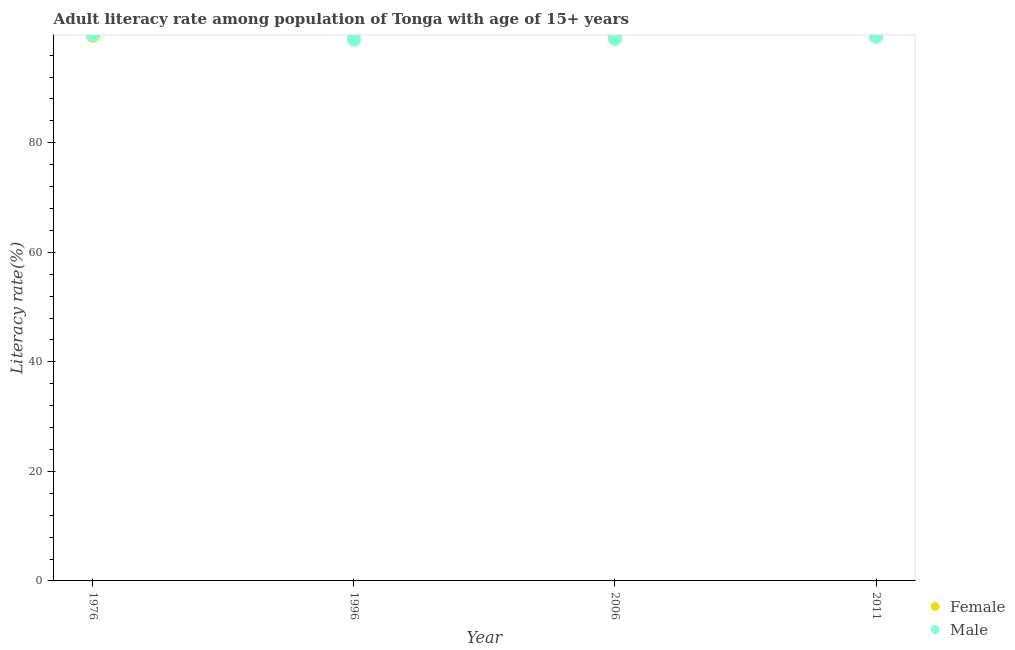What is the female adult literacy rate in 1976?
Your answer should be very brief. 99.53. Across all years, what is the maximum female adult literacy rate?
Ensure brevity in your answer.  99.53. Across all years, what is the minimum male adult literacy rate?
Give a very brief answer. 98.83. In which year was the male adult literacy rate maximum?
Your answer should be very brief. 1976. In which year was the female adult literacy rate minimum?
Offer a terse response. 1996. What is the total female adult literacy rate in the graph?
Provide a short and direct response. 397.02. What is the difference between the male adult literacy rate in 1996 and that in 2011?
Your answer should be very brief. -0.5. What is the difference between the male adult literacy rate in 2011 and the female adult literacy rate in 1976?
Offer a very short reply. -0.19. What is the average female adult literacy rate per year?
Make the answer very short. 99.25. In the year 1996, what is the difference between the male adult literacy rate and female adult literacy rate?
Offer a terse response. -0.14. In how many years, is the female adult literacy rate greater than 16 %?
Your response must be concise. 4. What is the ratio of the female adult literacy rate in 2006 to that in 2011?
Your answer should be compact. 1. What is the difference between the highest and the second highest male adult literacy rate?
Give a very brief answer. 0.32. What is the difference between the highest and the lowest male adult literacy rate?
Offer a very short reply. 0.82. Is the sum of the female adult literacy rate in 2006 and 2011 greater than the maximum male adult literacy rate across all years?
Your answer should be compact. Yes. Is the female adult literacy rate strictly greater than the male adult literacy rate over the years?
Offer a terse response. No. How many dotlines are there?
Make the answer very short. 2. How many years are there in the graph?
Offer a very short reply. 4. What is the difference between two consecutive major ticks on the Y-axis?
Your answer should be compact. 20. Does the graph contain any zero values?
Make the answer very short. No. Does the graph contain grids?
Offer a very short reply. No. Where does the legend appear in the graph?
Offer a very short reply. Bottom right. How many legend labels are there?
Provide a short and direct response. 2. How are the legend labels stacked?
Provide a short and direct response. Vertical. What is the title of the graph?
Keep it short and to the point. Adult literacy rate among population of Tonga with age of 15+ years. What is the label or title of the Y-axis?
Your answer should be compact. Literacy rate(%). What is the Literacy rate(%) of Female in 1976?
Keep it short and to the point. 99.53. What is the Literacy rate(%) in Male in 1976?
Offer a terse response. 99.66. What is the Literacy rate(%) in Female in 1996?
Make the answer very short. 98.98. What is the Literacy rate(%) of Male in 1996?
Ensure brevity in your answer.  98.83. What is the Literacy rate(%) in Female in 2006?
Your answer should be compact. 99.08. What is the Literacy rate(%) in Male in 2006?
Offer a terse response. 98.95. What is the Literacy rate(%) in Female in 2011?
Keep it short and to the point. 99.43. What is the Literacy rate(%) of Male in 2011?
Offer a terse response. 99.34. Across all years, what is the maximum Literacy rate(%) in Female?
Your answer should be very brief. 99.53. Across all years, what is the maximum Literacy rate(%) in Male?
Your answer should be very brief. 99.66. Across all years, what is the minimum Literacy rate(%) in Female?
Make the answer very short. 98.98. Across all years, what is the minimum Literacy rate(%) of Male?
Your answer should be very brief. 98.83. What is the total Literacy rate(%) in Female in the graph?
Your answer should be compact. 397.02. What is the total Literacy rate(%) of Male in the graph?
Provide a succinct answer. 396.78. What is the difference between the Literacy rate(%) in Female in 1976 and that in 1996?
Provide a succinct answer. 0.55. What is the difference between the Literacy rate(%) in Male in 1976 and that in 1996?
Provide a succinct answer. 0.82. What is the difference between the Literacy rate(%) of Female in 1976 and that in 2006?
Offer a terse response. 0.44. What is the difference between the Literacy rate(%) of Male in 1976 and that in 2006?
Keep it short and to the point. 0.7. What is the difference between the Literacy rate(%) of Female in 1976 and that in 2011?
Your response must be concise. 0.09. What is the difference between the Literacy rate(%) of Male in 1976 and that in 2011?
Provide a short and direct response. 0.32. What is the difference between the Literacy rate(%) of Female in 1996 and that in 2006?
Provide a succinct answer. -0.11. What is the difference between the Literacy rate(%) of Male in 1996 and that in 2006?
Provide a succinct answer. -0.12. What is the difference between the Literacy rate(%) in Female in 1996 and that in 2011?
Your answer should be very brief. -0.46. What is the difference between the Literacy rate(%) in Male in 1996 and that in 2011?
Your answer should be very brief. -0.5. What is the difference between the Literacy rate(%) of Female in 2006 and that in 2011?
Offer a very short reply. -0.35. What is the difference between the Literacy rate(%) in Male in 2006 and that in 2011?
Your answer should be compact. -0.38. What is the difference between the Literacy rate(%) of Female in 1976 and the Literacy rate(%) of Male in 1996?
Offer a terse response. 0.69. What is the difference between the Literacy rate(%) in Female in 1976 and the Literacy rate(%) in Male in 2006?
Give a very brief answer. 0.57. What is the difference between the Literacy rate(%) of Female in 1976 and the Literacy rate(%) of Male in 2011?
Offer a terse response. 0.19. What is the difference between the Literacy rate(%) in Female in 1996 and the Literacy rate(%) in Male in 2006?
Make the answer very short. 0.02. What is the difference between the Literacy rate(%) of Female in 1996 and the Literacy rate(%) of Male in 2011?
Offer a terse response. -0.36. What is the difference between the Literacy rate(%) of Female in 2006 and the Literacy rate(%) of Male in 2011?
Your answer should be compact. -0.25. What is the average Literacy rate(%) of Female per year?
Provide a succinct answer. 99.25. What is the average Literacy rate(%) of Male per year?
Your response must be concise. 99.2. In the year 1976, what is the difference between the Literacy rate(%) of Female and Literacy rate(%) of Male?
Offer a terse response. -0.13. In the year 1996, what is the difference between the Literacy rate(%) of Female and Literacy rate(%) of Male?
Make the answer very short. 0.14. In the year 2006, what is the difference between the Literacy rate(%) of Female and Literacy rate(%) of Male?
Offer a terse response. 0.13. In the year 2011, what is the difference between the Literacy rate(%) in Female and Literacy rate(%) in Male?
Provide a succinct answer. 0.1. What is the ratio of the Literacy rate(%) in Female in 1976 to that in 1996?
Offer a terse response. 1.01. What is the ratio of the Literacy rate(%) of Male in 1976 to that in 1996?
Offer a terse response. 1.01. What is the ratio of the Literacy rate(%) of Female in 1976 to that in 2006?
Your response must be concise. 1. What is the ratio of the Literacy rate(%) in Male in 1976 to that in 2006?
Offer a terse response. 1.01. What is the ratio of the Literacy rate(%) in Female in 1976 to that in 2011?
Offer a terse response. 1. What is the ratio of the Literacy rate(%) in Male in 1976 to that in 2011?
Give a very brief answer. 1. What is the ratio of the Literacy rate(%) of Male in 2006 to that in 2011?
Ensure brevity in your answer.  1. What is the difference between the highest and the second highest Literacy rate(%) of Female?
Provide a short and direct response. 0.09. What is the difference between the highest and the second highest Literacy rate(%) in Male?
Offer a terse response. 0.32. What is the difference between the highest and the lowest Literacy rate(%) of Female?
Your answer should be very brief. 0.55. What is the difference between the highest and the lowest Literacy rate(%) of Male?
Make the answer very short. 0.82. 